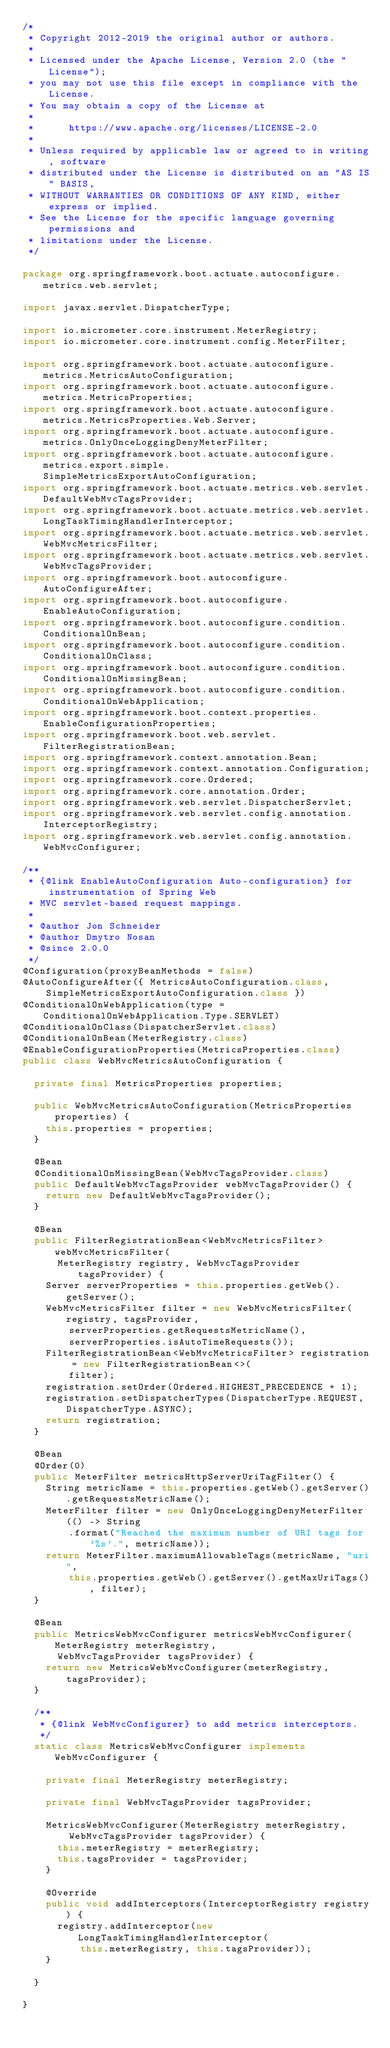<code> <loc_0><loc_0><loc_500><loc_500><_Java_>/*
 * Copyright 2012-2019 the original author or authors.
 *
 * Licensed under the Apache License, Version 2.0 (the "License");
 * you may not use this file except in compliance with the License.
 * You may obtain a copy of the License at
 *
 *      https://www.apache.org/licenses/LICENSE-2.0
 *
 * Unless required by applicable law or agreed to in writing, software
 * distributed under the License is distributed on an "AS IS" BASIS,
 * WITHOUT WARRANTIES OR CONDITIONS OF ANY KIND, either express or implied.
 * See the License for the specific language governing permissions and
 * limitations under the License.
 */

package org.springframework.boot.actuate.autoconfigure.metrics.web.servlet;

import javax.servlet.DispatcherType;

import io.micrometer.core.instrument.MeterRegistry;
import io.micrometer.core.instrument.config.MeterFilter;

import org.springframework.boot.actuate.autoconfigure.metrics.MetricsAutoConfiguration;
import org.springframework.boot.actuate.autoconfigure.metrics.MetricsProperties;
import org.springframework.boot.actuate.autoconfigure.metrics.MetricsProperties.Web.Server;
import org.springframework.boot.actuate.autoconfigure.metrics.OnlyOnceLoggingDenyMeterFilter;
import org.springframework.boot.actuate.autoconfigure.metrics.export.simple.SimpleMetricsExportAutoConfiguration;
import org.springframework.boot.actuate.metrics.web.servlet.DefaultWebMvcTagsProvider;
import org.springframework.boot.actuate.metrics.web.servlet.LongTaskTimingHandlerInterceptor;
import org.springframework.boot.actuate.metrics.web.servlet.WebMvcMetricsFilter;
import org.springframework.boot.actuate.metrics.web.servlet.WebMvcTagsProvider;
import org.springframework.boot.autoconfigure.AutoConfigureAfter;
import org.springframework.boot.autoconfigure.EnableAutoConfiguration;
import org.springframework.boot.autoconfigure.condition.ConditionalOnBean;
import org.springframework.boot.autoconfigure.condition.ConditionalOnClass;
import org.springframework.boot.autoconfigure.condition.ConditionalOnMissingBean;
import org.springframework.boot.autoconfigure.condition.ConditionalOnWebApplication;
import org.springframework.boot.context.properties.EnableConfigurationProperties;
import org.springframework.boot.web.servlet.FilterRegistrationBean;
import org.springframework.context.annotation.Bean;
import org.springframework.context.annotation.Configuration;
import org.springframework.core.Ordered;
import org.springframework.core.annotation.Order;
import org.springframework.web.servlet.DispatcherServlet;
import org.springframework.web.servlet.config.annotation.InterceptorRegistry;
import org.springframework.web.servlet.config.annotation.WebMvcConfigurer;

/**
 * {@link EnableAutoConfiguration Auto-configuration} for instrumentation of Spring Web
 * MVC servlet-based request mappings.
 *
 * @author Jon Schneider
 * @author Dmytro Nosan
 * @since 2.0.0
 */
@Configuration(proxyBeanMethods = false)
@AutoConfigureAfter({ MetricsAutoConfiguration.class,
		SimpleMetricsExportAutoConfiguration.class })
@ConditionalOnWebApplication(type = ConditionalOnWebApplication.Type.SERVLET)
@ConditionalOnClass(DispatcherServlet.class)
@ConditionalOnBean(MeterRegistry.class)
@EnableConfigurationProperties(MetricsProperties.class)
public class WebMvcMetricsAutoConfiguration {

	private final MetricsProperties properties;

	public WebMvcMetricsAutoConfiguration(MetricsProperties properties) {
		this.properties = properties;
	}

	@Bean
	@ConditionalOnMissingBean(WebMvcTagsProvider.class)
	public DefaultWebMvcTagsProvider webMvcTagsProvider() {
		return new DefaultWebMvcTagsProvider();
	}

	@Bean
	public FilterRegistrationBean<WebMvcMetricsFilter> webMvcMetricsFilter(
			MeterRegistry registry, WebMvcTagsProvider tagsProvider) {
		Server serverProperties = this.properties.getWeb().getServer();
		WebMvcMetricsFilter filter = new WebMvcMetricsFilter(registry, tagsProvider,
				serverProperties.getRequestsMetricName(),
				serverProperties.isAutoTimeRequests());
		FilterRegistrationBean<WebMvcMetricsFilter> registration = new FilterRegistrationBean<>(
				filter);
		registration.setOrder(Ordered.HIGHEST_PRECEDENCE + 1);
		registration.setDispatcherTypes(DispatcherType.REQUEST, DispatcherType.ASYNC);
		return registration;
	}

	@Bean
	@Order(0)
	public MeterFilter metricsHttpServerUriTagFilter() {
		String metricName = this.properties.getWeb().getServer().getRequestsMetricName();
		MeterFilter filter = new OnlyOnceLoggingDenyMeterFilter(() -> String
				.format("Reached the maximum number of URI tags for '%s'.", metricName));
		return MeterFilter.maximumAllowableTags(metricName, "uri",
				this.properties.getWeb().getServer().getMaxUriTags(), filter);
	}

	@Bean
	public MetricsWebMvcConfigurer metricsWebMvcConfigurer(MeterRegistry meterRegistry,
			WebMvcTagsProvider tagsProvider) {
		return new MetricsWebMvcConfigurer(meterRegistry, tagsProvider);
	}

	/**
	 * {@link WebMvcConfigurer} to add metrics interceptors.
	 */
	static class MetricsWebMvcConfigurer implements WebMvcConfigurer {

		private final MeterRegistry meterRegistry;

		private final WebMvcTagsProvider tagsProvider;

		MetricsWebMvcConfigurer(MeterRegistry meterRegistry,
				WebMvcTagsProvider tagsProvider) {
			this.meterRegistry = meterRegistry;
			this.tagsProvider = tagsProvider;
		}

		@Override
		public void addInterceptors(InterceptorRegistry registry) {
			registry.addInterceptor(new LongTaskTimingHandlerInterceptor(
					this.meterRegistry, this.tagsProvider));
		}

	}

}
</code> 